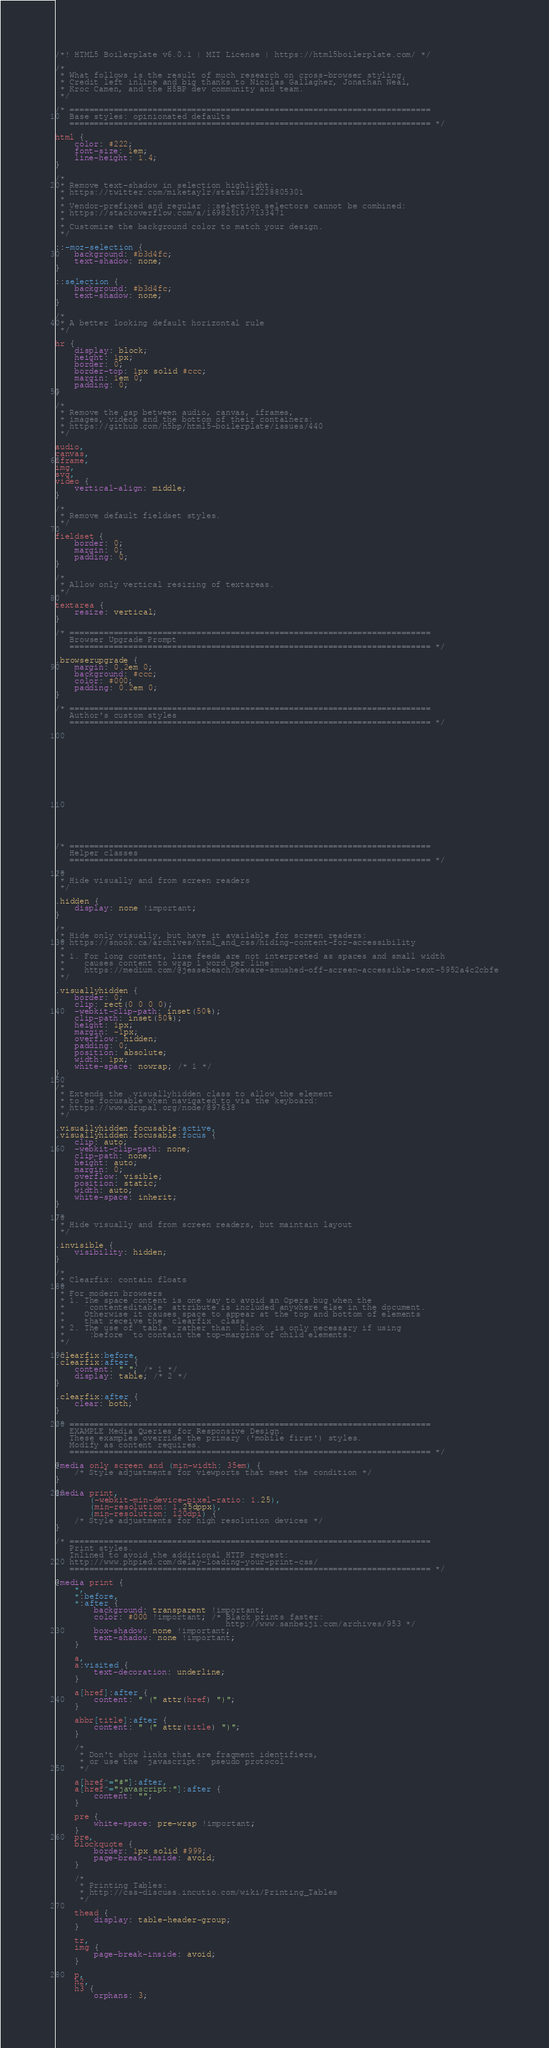<code> <loc_0><loc_0><loc_500><loc_500><_CSS_>/*! HTML5 Boilerplate v6.0.1 | MIT License | https://html5boilerplate.com/ */

/*
 * What follows is the result of much research on cross-browser styling.
 * Credit left inline and big thanks to Nicolas Gallagher, Jonathan Neal,
 * Kroc Camen, and the H5BP dev community and team.
 */

/* ==========================================================================
   Base styles: opinionated defaults
   ========================================================================== */

html {
    color: #222;
    font-size: 1em;
    line-height: 1.4;
}

/*
 * Remove text-shadow in selection highlight:
 * https://twitter.com/miketaylr/status/12228805301
 *
 * Vendor-prefixed and regular ::selection selectors cannot be combined:
 * https://stackoverflow.com/a/16982510/7133471
 *
 * Customize the background color to match your design.
 */

::-moz-selection {
    background: #b3d4fc;
    text-shadow: none;
}

::selection {
    background: #b3d4fc;
    text-shadow: none;
}

/*
 * A better looking default horizontal rule
 */

hr {
    display: block;
    height: 1px;
    border: 0;
    border-top: 1px solid #ccc;
    margin: 1em 0;
    padding: 0;
}

/*
 * Remove the gap between audio, canvas, iframes,
 * images, videos and the bottom of their containers:
 * https://github.com/h5bp/html5-boilerplate/issues/440
 */

audio,
canvas,
iframe,
img,
svg,
video {
    vertical-align: middle;
}

/*
 * Remove default fieldset styles.
 */

fieldset {
    border: 0;
    margin: 0;
    padding: 0;
}

/*
 * Allow only vertical resizing of textareas.
 */

textarea {
    resize: vertical;
}

/* ==========================================================================
   Browser Upgrade Prompt
   ========================================================================== */

.browserupgrade {
    margin: 0.2em 0;
    background: #ccc;
    color: #000;
    padding: 0.2em 0;
}

/* ==========================================================================
   Author's custom styles
   ========================================================================== */

















/* ==========================================================================
   Helper classes
   ========================================================================== */

/*
 * Hide visually and from screen readers
 */

.hidden {
    display: none !important;
}

/*
 * Hide only visually, but have it available for screen readers:
 * https://snook.ca/archives/html_and_css/hiding-content-for-accessibility
 *
 * 1. For long content, line feeds are not interpreted as spaces and small width
 *    causes content to wrap 1 word per line:
 *    https://medium.com/@jessebeach/beware-smushed-off-screen-accessible-text-5952a4c2cbfe
 */

.visuallyhidden {
    border: 0;
    clip: rect(0 0 0 0);
    -webkit-clip-path: inset(50%);
    clip-path: inset(50%);
    height: 1px;
    margin: -1px;
    overflow: hidden;
    padding: 0;
    position: absolute;
    width: 1px;
    white-space: nowrap; /* 1 */
}

/*
 * Extends the .visuallyhidden class to allow the element
 * to be focusable when navigated to via the keyboard:
 * https://www.drupal.org/node/897638
 */

.visuallyhidden.focusable:active,
.visuallyhidden.focusable:focus {
    clip: auto;
    -webkit-clip-path: none;
    clip-path: none;
    height: auto;
    margin: 0;
    overflow: visible;
    position: static;
    width: auto;
    white-space: inherit;
}

/*
 * Hide visually and from screen readers, but maintain layout
 */

.invisible {
    visibility: hidden;
}

/*
 * Clearfix: contain floats
 *
 * For modern browsers
 * 1. The space content is one way to avoid an Opera bug when the
 *    `contenteditable` attribute is included anywhere else in the document.
 *    Otherwise it causes space to appear at the top and bottom of elements
 *    that receive the `clearfix` class.
 * 2. The use of `table` rather than `block` is only necessary if using
 *    `:before` to contain the top-margins of child elements.
 */

.clearfix:before,
.clearfix:after {
    content: " "; /* 1 */
    display: table; /* 2 */
}

.clearfix:after {
    clear: both;
}

/* ==========================================================================
   EXAMPLE Media Queries for Responsive Design.
   These examples override the primary ('mobile first') styles.
   Modify as content requires.
   ========================================================================== */

@media only screen and (min-width: 35em) {
    /* Style adjustments for viewports that meet the condition */
}

@media print,
       (-webkit-min-device-pixel-ratio: 1.25),
       (min-resolution: 1.25dppx),
       (min-resolution: 120dpi) {
    /* Style adjustments for high resolution devices */
}

/* ==========================================================================
   Print styles.
   Inlined to avoid the additional HTTP request:
   http://www.phpied.com/delay-loading-your-print-css/
   ========================================================================== */

@media print {
    *,
    *:before,
    *:after {
        background: transparent !important;
        color: #000 !important; /* Black prints faster:
                                   http://www.sanbeiji.com/archives/953 */
        box-shadow: none !important;
        text-shadow: none !important;
    }

    a,
    a:visited {
        text-decoration: underline;
    }

    a[href]:after {
        content: " (" attr(href) ")";
    }

    abbr[title]:after {
        content: " (" attr(title) ")";
    }

    /*
     * Don't show links that are fragment identifiers,
     * or use the `javascript:` pseudo protocol
     */

    a[href^="#"]:after,
    a[href^="javascript:"]:after {
        content: "";
    }

    pre {
        white-space: pre-wrap !important;
    }
    pre,
    blockquote {
        border: 1px solid #999;
        page-break-inside: avoid;
    }

    /*
     * Printing Tables:
     * http://css-discuss.incutio.com/wiki/Printing_Tables
     */

    thead {
        display: table-header-group;
    }

    tr,
    img {
        page-break-inside: avoid;
    }

    p,
    h2,
    h3 {
        orphans: 3;</code> 